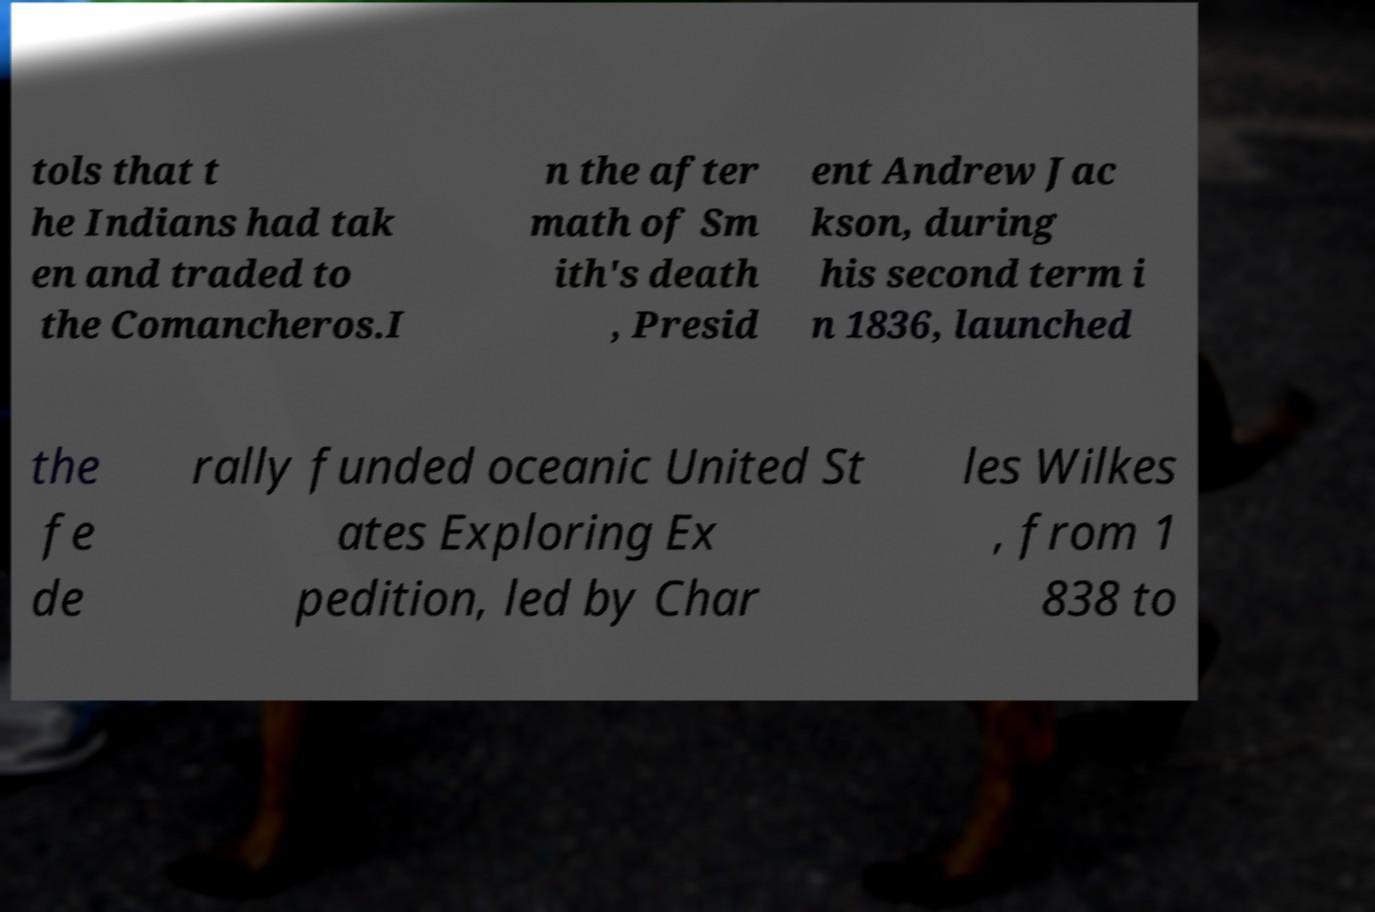What messages or text are displayed in this image? I need them in a readable, typed format. tols that t he Indians had tak en and traded to the Comancheros.I n the after math of Sm ith's death , Presid ent Andrew Jac kson, during his second term i n 1836, launched the fe de rally funded oceanic United St ates Exploring Ex pedition, led by Char les Wilkes , from 1 838 to 